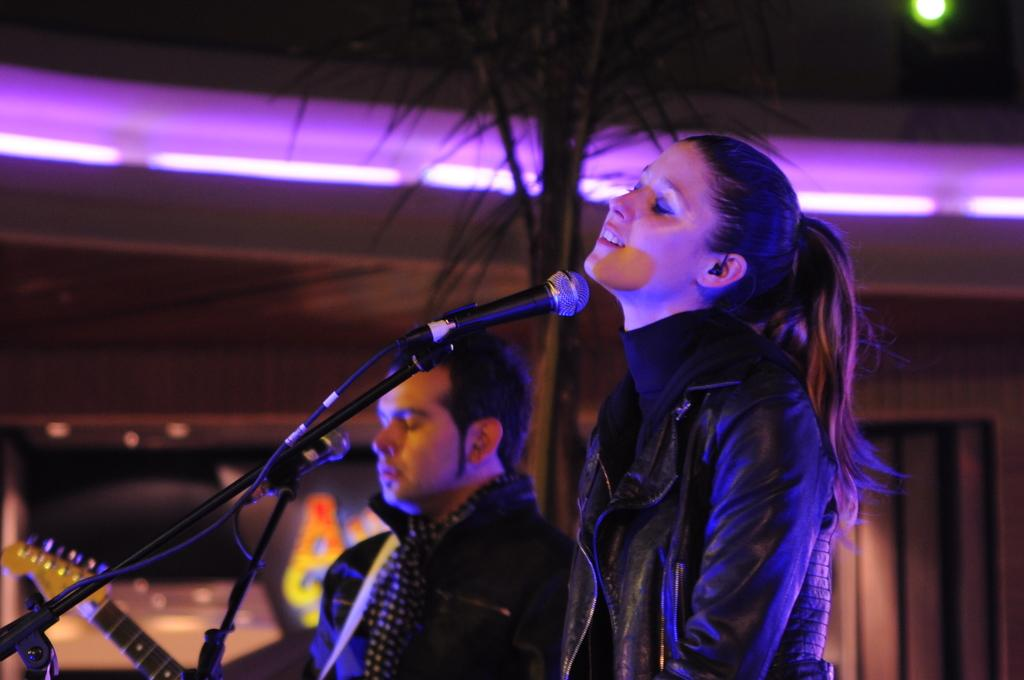What is the lady in the image wearing? The lady in the image is wearing a black jacket. What is the lady doing in the image? The lady is standing in the image. What is the man in the image doing? The man is playing a guitar in the image. What objects are present in front of the lady and the man? There are microphones in front of the lady and the man in the image. What can be seen in the background of the image? There is a tree with lights on the wall in the background of the image. What type of government is depicted in the image? There is no depiction of a government in the image; it features a lady and a man with microphones and a tree with lights in the background. What is the yoke used for in the image? There is no yoke present in the image. 